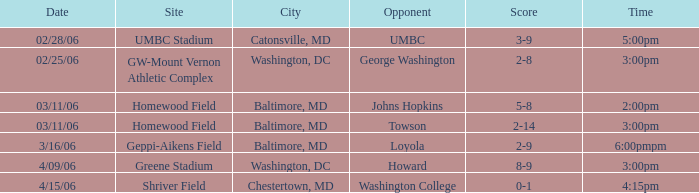Who was the Opponent at Homewood Field with a Score of 5-8? Johns Hopkins. 